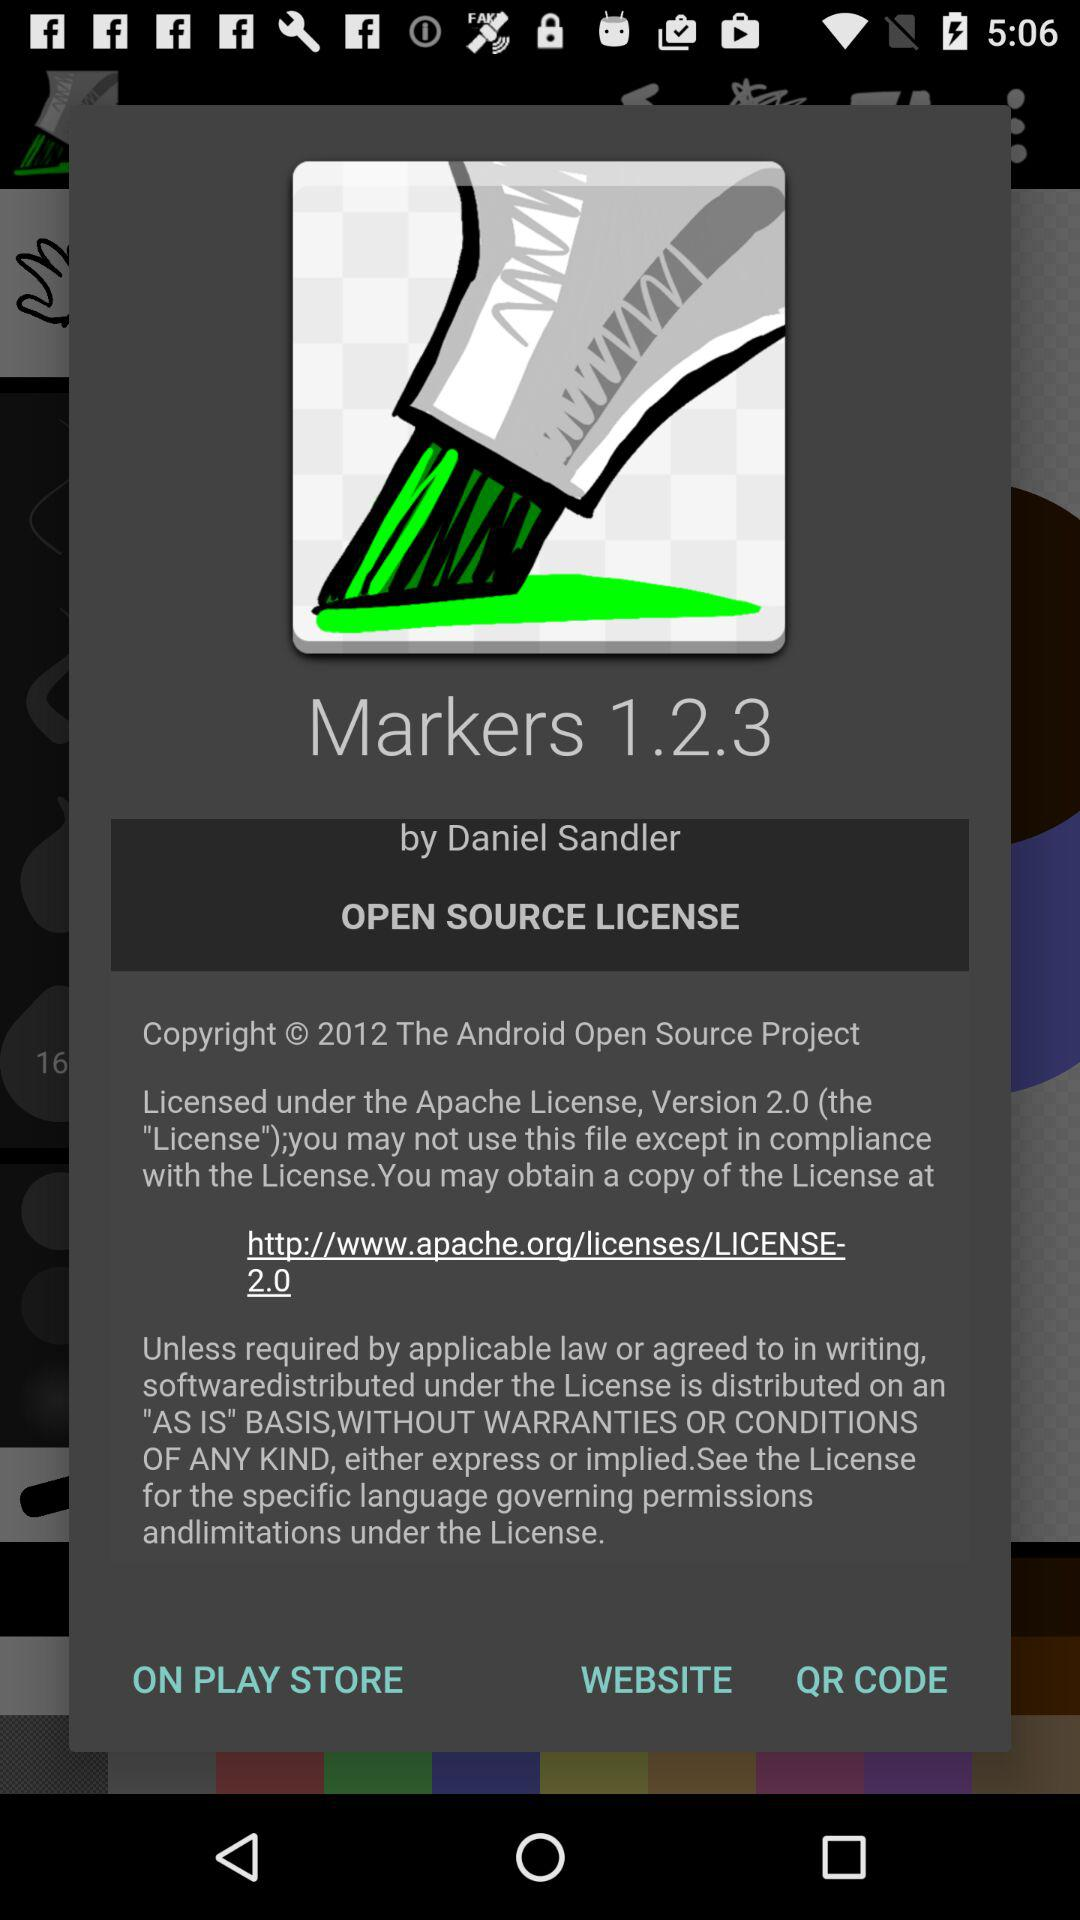What is the app name? The app's name is "Markers 1.2.3". 